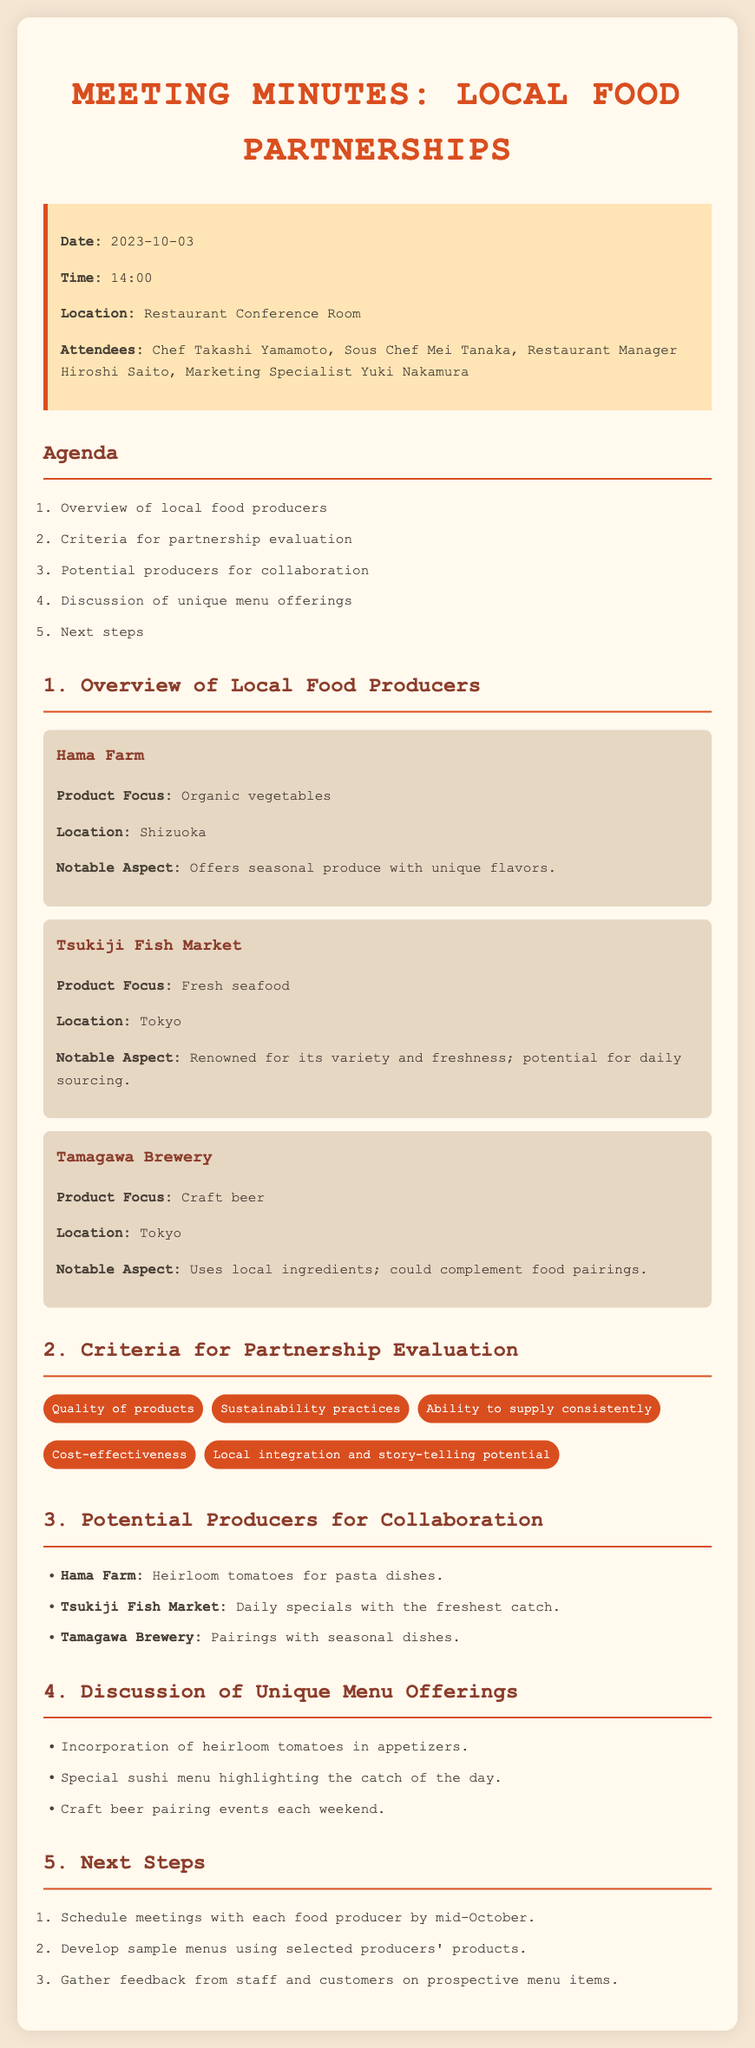what is the date of the meeting? The date of the meeting is clearly stated in the info box as October 3, 2023.
Answer: October 3, 2023 who is the Restaurant Manager? The name of the Restaurant Manager is listed in the attendees section of the minutes.
Answer: Hiroshi Saito what is the product focus of Hama Farm? The document specifies the product focus of Hama Farm in the overview section.
Answer: Organic vegetables what is a notable aspect of Tsukiji Fish Market? The notable aspect of Tsukiji Fish Market is mentioned in the producer overview, discussing its freshness.
Answer: Renowned for its variety and freshness what is one criteria for partnership evaluation? The criteria for partnership evaluation are listed in a specific list in the document.
Answer: Quality of products how many potential producers for collaboration were mentioned? The number of potential producers is noted in the collaboration section.
Answer: Three what unique menu offering was discussed related to heirloom tomatoes? The unique menu offerings section mentions a specific use of heirloom tomatoes.
Answer: Incorporation in appetizers when should meetings with each food producer be scheduled? The next steps section specifies a timeline for scheduling meetings with producers.
Answer: Mid-October 